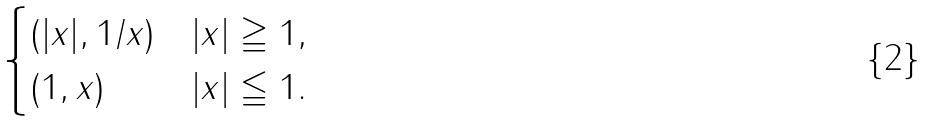<formula> <loc_0><loc_0><loc_500><loc_500>\begin{cases} ( | x | , 1 / x ) & | x | \geqq 1 , \\ ( 1 , x ) & | x | \leqq 1 . \\ \end{cases}</formula> 